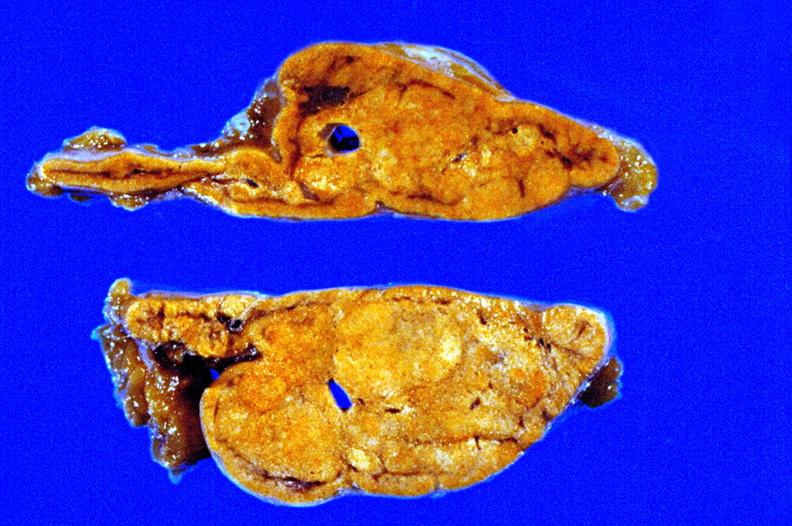does this image show fixed tissue cut surface close-up view rather good apparently non-functional?
Answer the question using a single word or phrase. Yes 